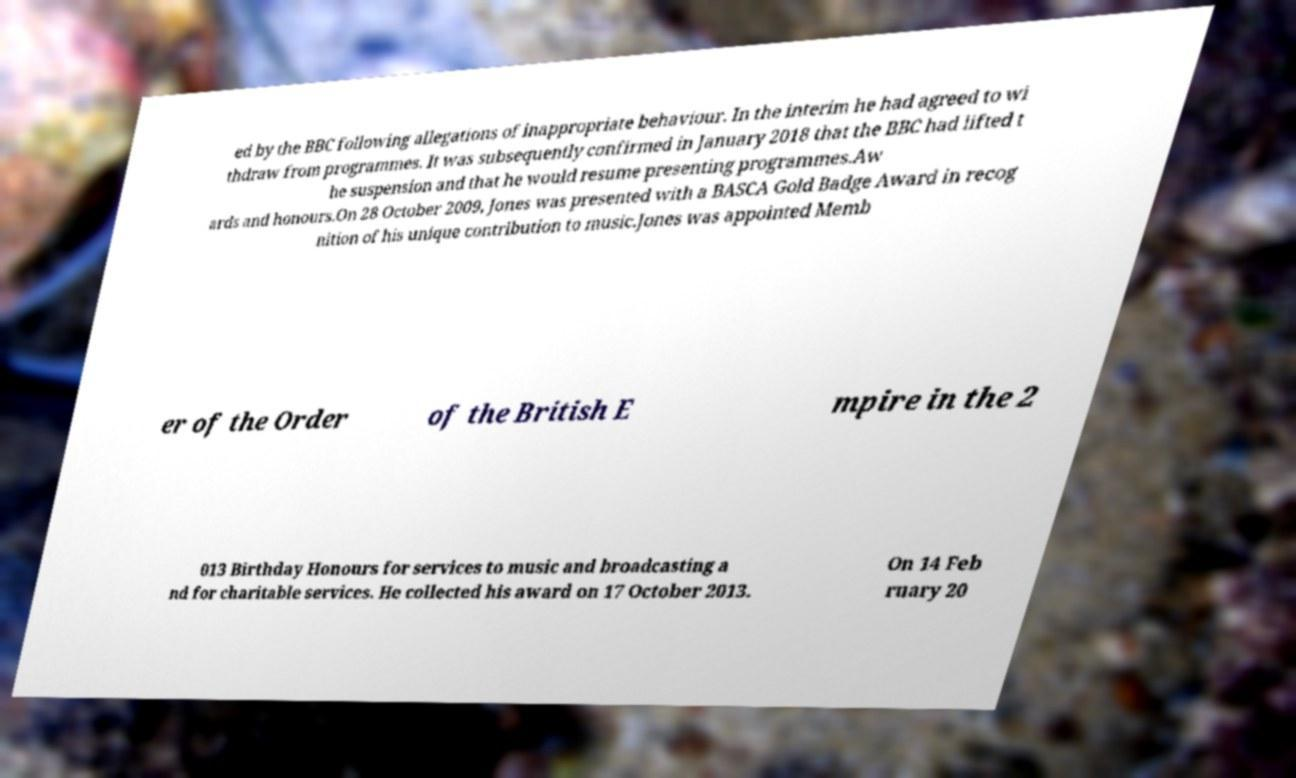What messages or text are displayed in this image? I need them in a readable, typed format. ed by the BBC following allegations of inappropriate behaviour. In the interim he had agreed to wi thdraw from programmes. It was subsequently confirmed in January 2018 that the BBC had lifted t he suspension and that he would resume presenting programmes.Aw ards and honours.On 28 October 2009, Jones was presented with a BASCA Gold Badge Award in recog nition of his unique contribution to music.Jones was appointed Memb er of the Order of the British E mpire in the 2 013 Birthday Honours for services to music and broadcasting a nd for charitable services. He collected his award on 17 October 2013. On 14 Feb ruary 20 